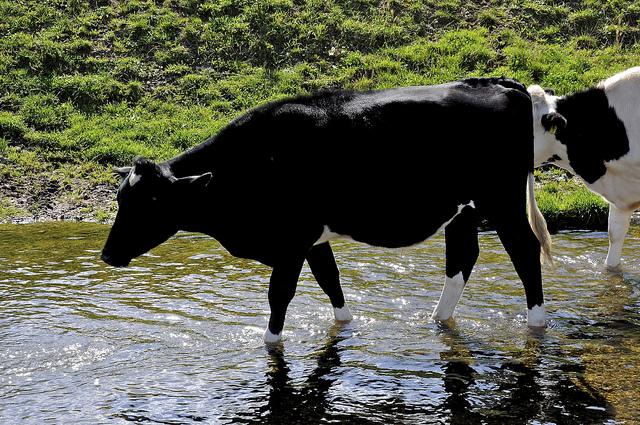What are the cows doing?
Be succinct. Walking. What type of liquid is this man gathering?
Short answer required. Water. How many cows are white?
Write a very short answer. 1. What are the cows standing in?
Write a very short answer. Water. What number is tagged on the cow?
Answer briefly. 0. 